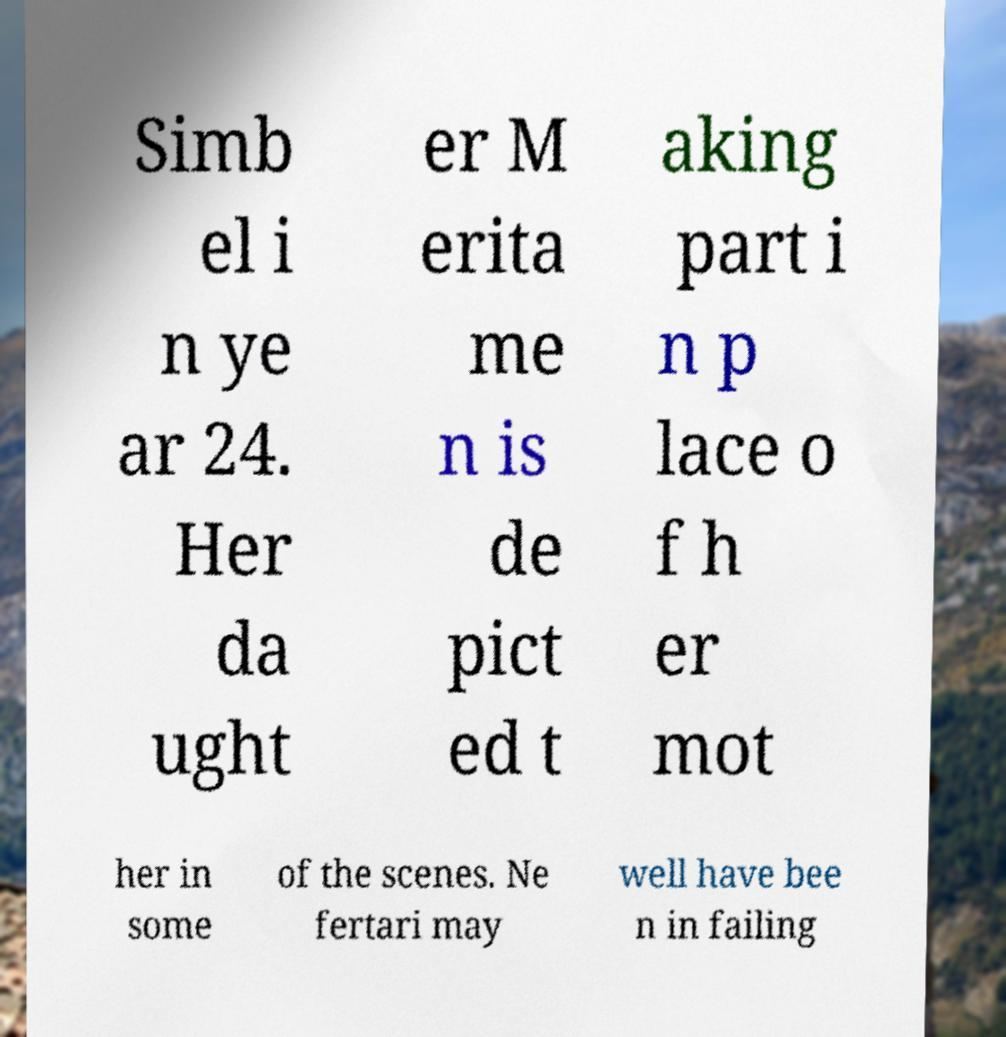For documentation purposes, I need the text within this image transcribed. Could you provide that? Simb el i n ye ar 24. Her da ught er M erita me n is de pict ed t aking part i n p lace o f h er mot her in some of the scenes. Ne fertari may well have bee n in failing 